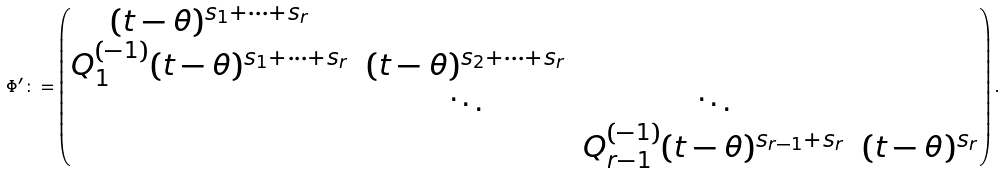Convert formula to latex. <formula><loc_0><loc_0><loc_500><loc_500>\Phi ^ { \prime } \colon = \begin{pmatrix} ( t - \theta ) ^ { s _ { 1 } + \cdots + s _ { r } } & & & \\ Q _ { 1 } ^ { ( - 1 ) } ( t - \theta ) ^ { s _ { 1 } + \cdots + s _ { r } } & ( t - \theta ) ^ { s _ { 2 } + \cdots + s _ { r } } & & \\ & \ddots & \ddots & \\ & & Q _ { r - 1 } ^ { ( - 1 ) } ( t - \theta ) ^ { s _ { r - 1 } + s _ { r } } & ( t - \theta ) ^ { s _ { r } } \\ \end{pmatrix} .</formula> 